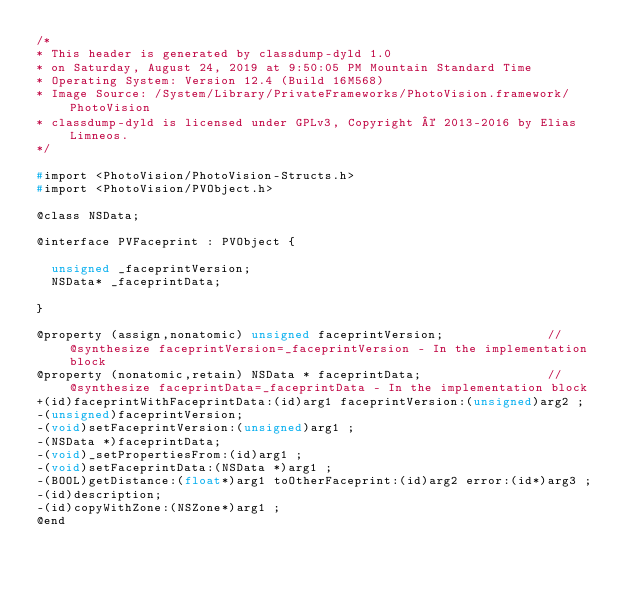Convert code to text. <code><loc_0><loc_0><loc_500><loc_500><_C_>/*
* This header is generated by classdump-dyld 1.0
* on Saturday, August 24, 2019 at 9:50:05 PM Mountain Standard Time
* Operating System: Version 12.4 (Build 16M568)
* Image Source: /System/Library/PrivateFrameworks/PhotoVision.framework/PhotoVision
* classdump-dyld is licensed under GPLv3, Copyright © 2013-2016 by Elias Limneos.
*/

#import <PhotoVision/PhotoVision-Structs.h>
#import <PhotoVision/PVObject.h>

@class NSData;

@interface PVFaceprint : PVObject {

	unsigned _faceprintVersion;
	NSData* _faceprintData;

}

@property (assign,nonatomic) unsigned faceprintVersion;              //@synthesize faceprintVersion=_faceprintVersion - In the implementation block
@property (nonatomic,retain) NSData * faceprintData;                 //@synthesize faceprintData=_faceprintData - In the implementation block
+(id)faceprintWithFaceprintData:(id)arg1 faceprintVersion:(unsigned)arg2 ;
-(unsigned)faceprintVersion;
-(void)setFaceprintVersion:(unsigned)arg1 ;
-(NSData *)faceprintData;
-(void)_setPropertiesFrom:(id)arg1 ;
-(void)setFaceprintData:(NSData *)arg1 ;
-(BOOL)getDistance:(float*)arg1 toOtherFaceprint:(id)arg2 error:(id*)arg3 ;
-(id)description;
-(id)copyWithZone:(NSZone*)arg1 ;
@end

</code> 